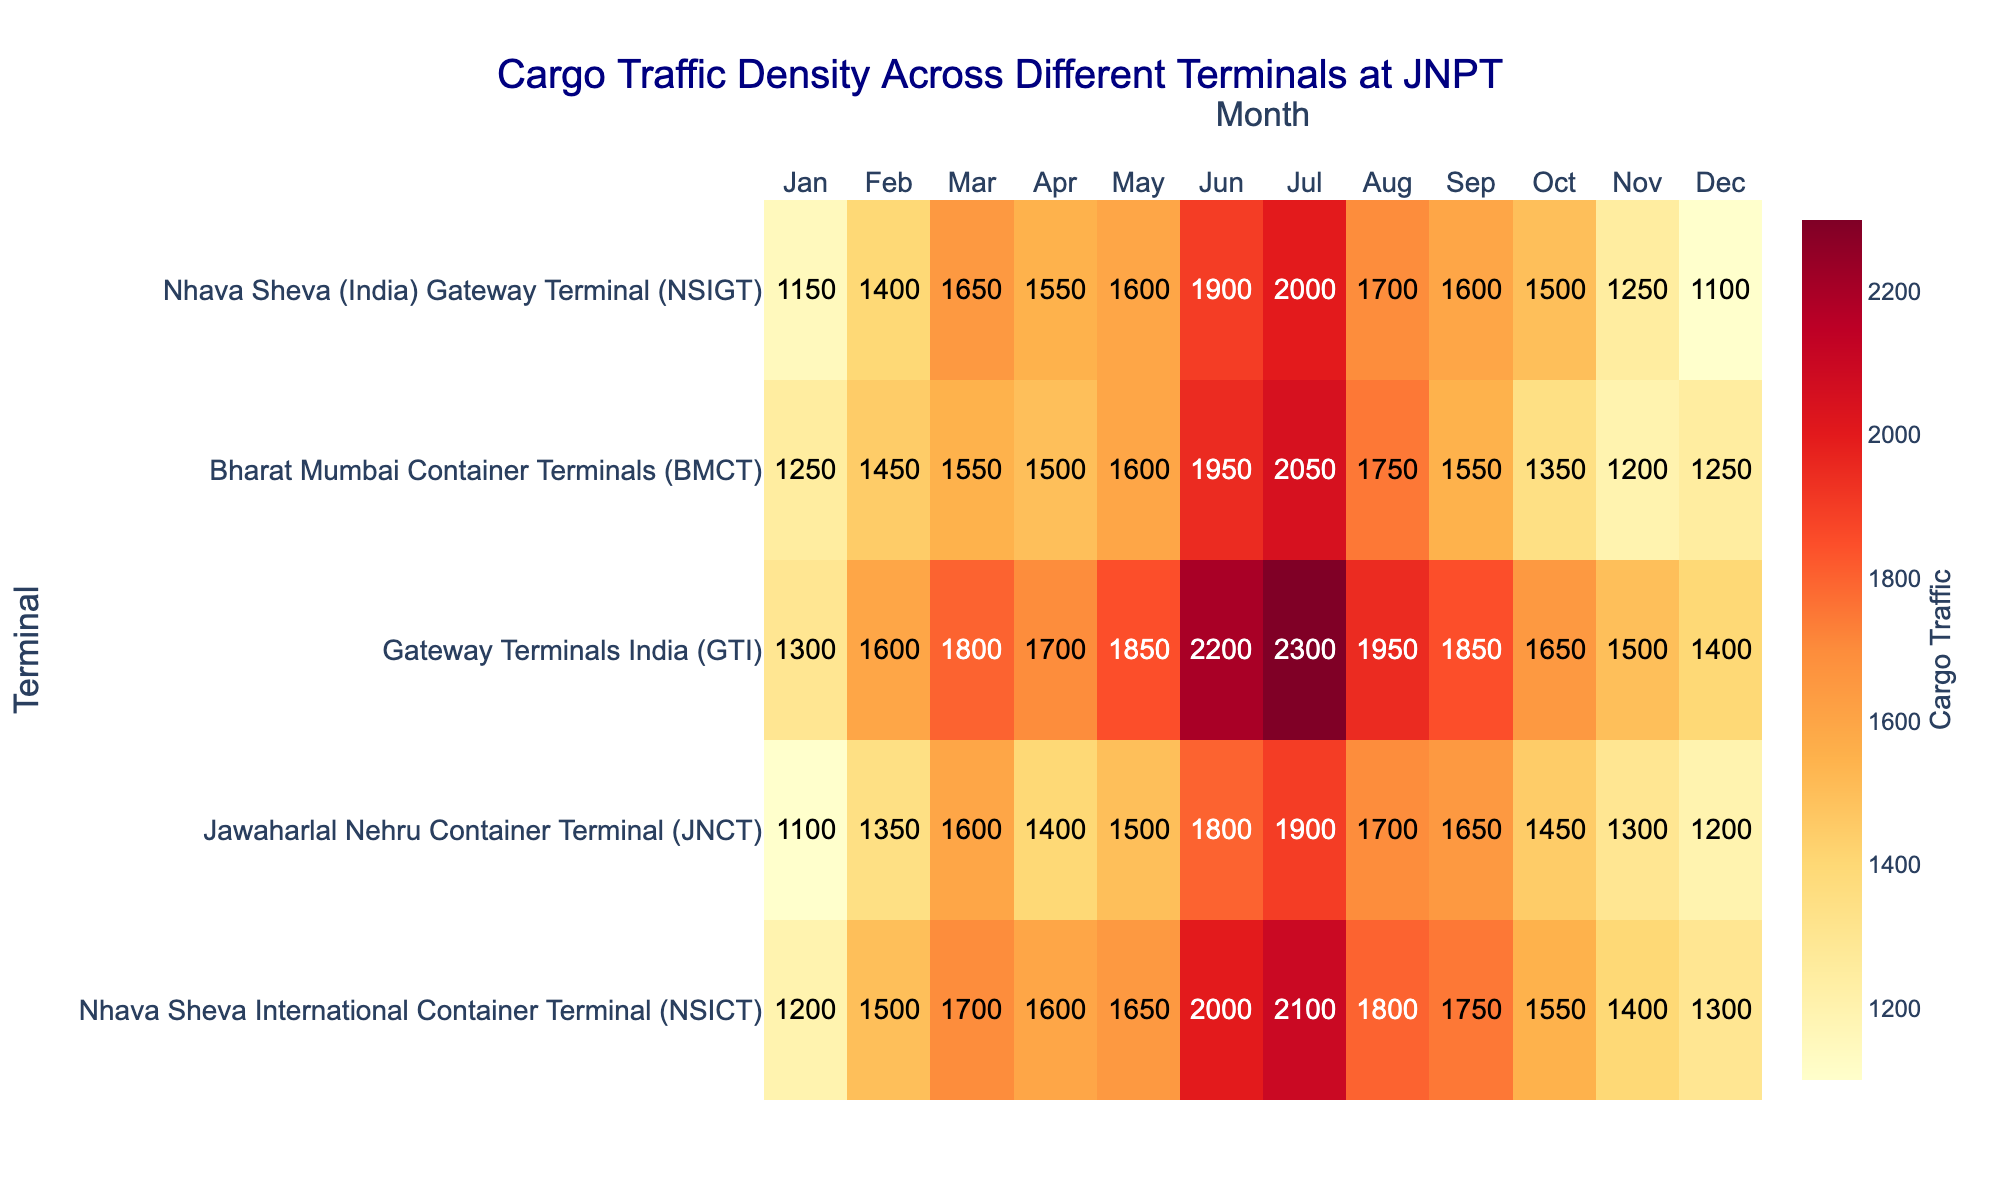How many terminals are displayed in the heatmap? There are five terminals listed on the y-axis of the heatmap: NHICT, JNCT, GTI, BMCT, and NSIGT.
Answer: 5 What is the cargo traffic density at GTI in July? Find the intersection of Gateway Terminals India (GTI) and the month July in the heatmap data; the number is directly provided.
Answer: 2300 Which terminal had the highest cargo traffic density in May? Look at the row corresponding to May for each terminal and identify the terminal with the highest number. GTI has the highest value (1850).
Answer: GTI Compare the cargo traffic in January for NSICT and BMCT. Which one is higher? Locate the January cargo traffic figures for both NSICT (1200) and BMCT (1250). BMCT has a higher value.
Answer: BMCT What is the total cargo traffic for JNCT in the second half of the year (Jul-Dec)? Add the values for JNCT from July to December: 1900 + 1700 + 1650 + 1450 + 1300 + 1200 = 9200.
Answer: 9200 Which month shows the highest cargo traffic for all terminals combined? Add the cargo traffic for all terminals for each month and compare the sums. June has the highest total (2000+1800+2200+1950+1900=9850).
Answer: June What is the monthly average cargo traffic for the NSIGT terminal in the first quarter of the year (Q1: Jan-Mar)? The first quarter data for NSIGT is 1150 (Jan) + 1400 (Feb) + 1650 (Mar). Average = (1150+1400+1650)/3 = 1400.
Answer: 1400 Identify the month where BMCT had the least cargo traffic. Look through the BMCT row and find the smallest number which appears in November (1200).
Answer: November By how much did the cargo traffic at NSICT increase from January to February? Subtract the cargo traffic value in January (1200) from the value in February (1500): 1500 - 1200 = 300.
Answer: 300 